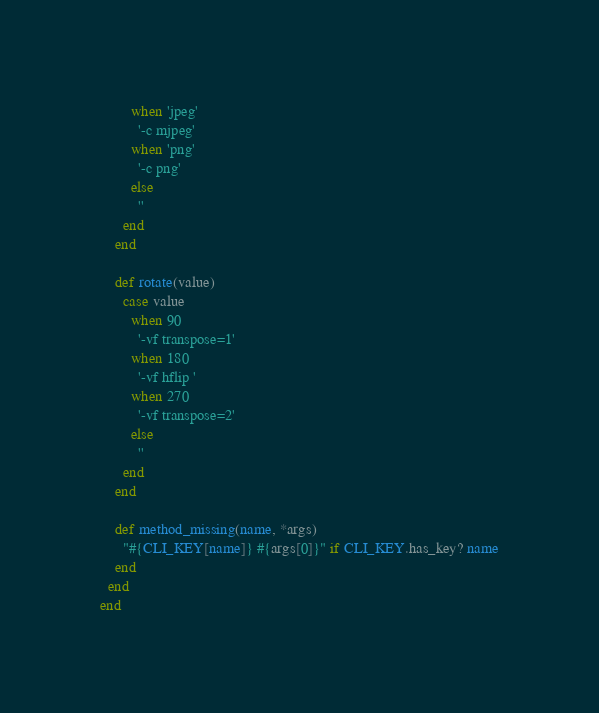<code> <loc_0><loc_0><loc_500><loc_500><_Ruby_>        when 'jpeg'
          '-c mjpeg'
        when 'png'
          '-c png'
        else
          ''
      end
    end

    def rotate(value)
      case value
        when 90
          '-vf transpose=1'
        when 180
          '-vf hflip '
        when 270
          '-vf transpose=2'
        else
          ''
      end
    end

    def method_missing(name, *args)
      "#{CLI_KEY[name]} #{args[0]}" if CLI_KEY.has_key? name
    end
  end
end
</code> 